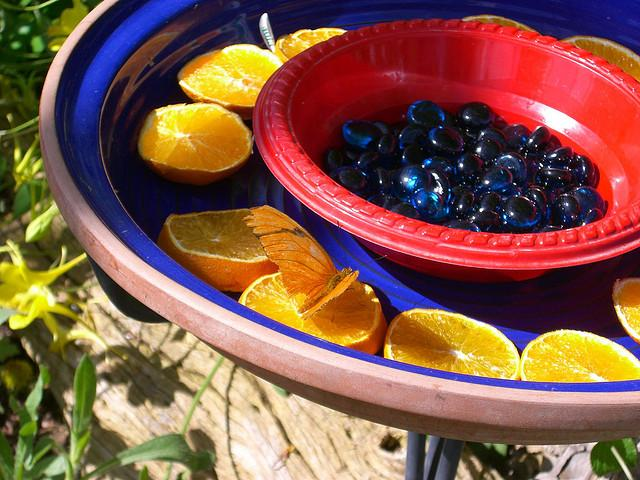What food group is being served?

Choices:
A) vegetables
B) meat
C) dairy
D) fruits fruits 